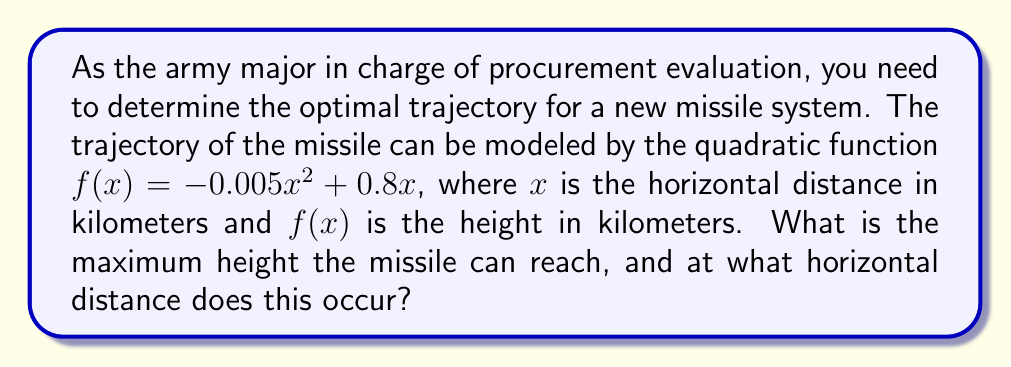Can you answer this question? To solve this problem, we need to follow these steps:

1) The quadratic function given is $f(x) = -0.005x^2 + 0.8x$

2) To find the maximum height, we need to find the vertex of this parabola. For a quadratic function in the form $f(x) = ax^2 + bx + c$, the x-coordinate of the vertex is given by $x = -\frac{b}{2a}$

3) In our case, $a = -0.005$ and $b = 0.8$

4) Substituting these values:

   $x = -\frac{0.8}{2(-0.005)} = -\frac{0.8}{-0.01} = 80$

5) This means the maximum height occurs when $x = 80$ km

6) To find the maximum height, we substitute this x-value back into our original function:

   $f(80) = -0.005(80)^2 + 0.8(80)$
          $= -0.005(6400) + 64$
          $= -32 + 64$
          $= 32$

Therefore, the maximum height is 32 km and it occurs at a horizontal distance of 80 km.

[asy]
import graph;
size(200,200);
real f(real x) {return -0.005x^2 + 0.8x;}
draw(graph(f,0,160));
dot((80,32));
label("(80,32)",(80,32),NE);
xaxis("x (km)",0,160,Arrow);
yaxis("y (km)",0,40,Arrow);
[/asy]
Answer: The missile reaches a maximum height of 32 km at a horizontal distance of 80 km. 